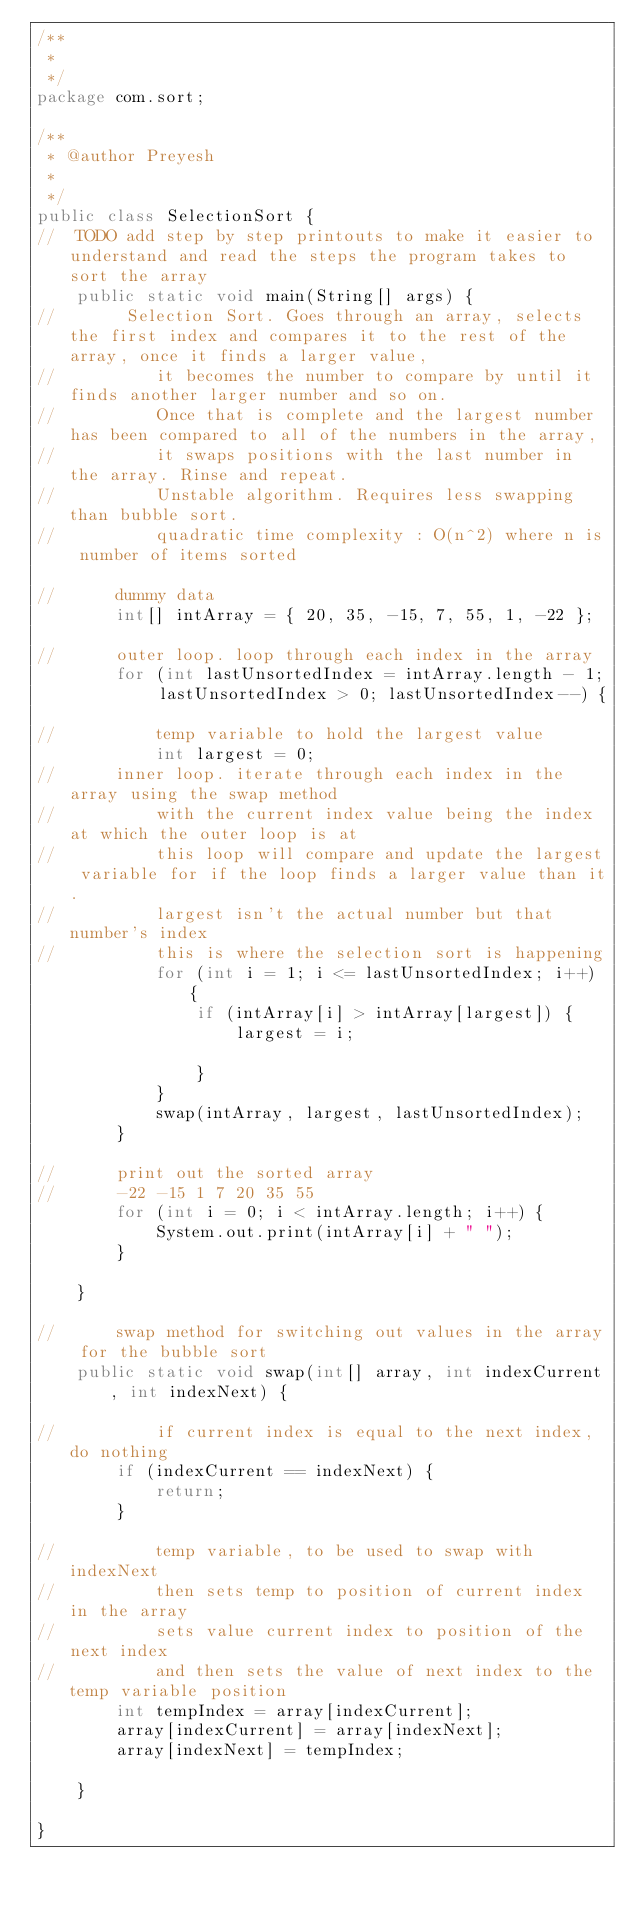Convert code to text. <code><loc_0><loc_0><loc_500><loc_500><_Java_>/**
 * 
 */
package com.sort;

/**
 * @author Preyesh
 *
 */
public class SelectionSort {
//	TODO add step by step printouts to make it easier to understand and read the steps the program takes to sort the array
	public static void main(String[] args) {
//		 Selection Sort. Goes through an array, selects the first index and compares it to the rest of the array, once it finds a larger value,
//			it becomes the number to compare by until it finds another larger number and so on. 
//			Once that is complete and the largest number has been compared to all of the numbers in the array,
//			it swaps positions with the last number in the array. Rinse and repeat.
//			Unstable algorithm. Requires less swapping than bubble sort.
//			quadratic time complexity : O(n^2) where n is number of items sorted

//		dummy data
		int[] intArray = { 20, 35, -15, 7, 55, 1, -22 };

//		outer loop. loop through each index in the array
		for (int lastUnsortedIndex = intArray.length - 1; lastUnsortedIndex > 0; lastUnsortedIndex--) {

//			temp variable to hold the largest value
			int largest = 0;
//		inner loop.	iterate through each index in the array using the swap method
//			with the current index value being the index at which the outer loop is at
//			this loop will compare and update the largest variable for if the loop finds a larger value than it.
//			largest isn't the actual number but that number's index
//			this is where the selection sort is happening
			for (int i = 1; i <= lastUnsortedIndex; i++) {
				if (intArray[i] > intArray[largest]) {
					largest = i;

				}
			}
			swap(intArray, largest, lastUnsortedIndex);
		}

//		print out the sorted array
//		-22 -15 1 7 20 35 55 
		for (int i = 0; i < intArray.length; i++) {
			System.out.print(intArray[i] + " ");
		}

	}

//		swap method for switching out values in the array for the bubble sort
	public static void swap(int[] array, int indexCurrent, int indexNext) {

//			if current index is equal to the next index, do nothing
		if (indexCurrent == indexNext) {
			return;
		}

//			temp variable, to be used to swap with indexNext
//			then sets temp to position of current index in the array
//			sets value current index to position of the next index 
//			and then sets the value of next index to the temp variable position
		int tempIndex = array[indexCurrent];
		array[indexCurrent] = array[indexNext];
		array[indexNext] = tempIndex;

	}

}
</code> 